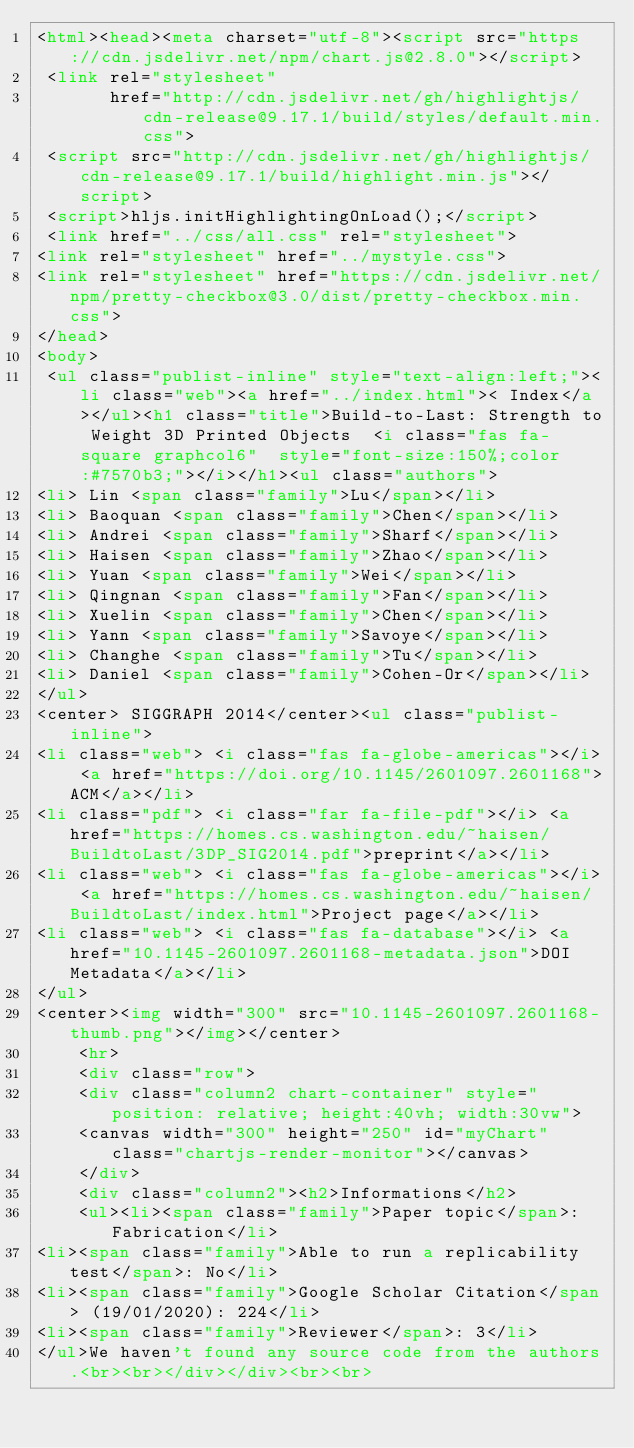<code> <loc_0><loc_0><loc_500><loc_500><_HTML_><html><head><meta charset="utf-8"><script src="https://cdn.jsdelivr.net/npm/chart.js@2.8.0"></script>
 <link rel="stylesheet"
       href="http://cdn.jsdelivr.net/gh/highlightjs/cdn-release@9.17.1/build/styles/default.min.css">
 <script src="http://cdn.jsdelivr.net/gh/highlightjs/cdn-release@9.17.1/build/highlight.min.js"></script>
 <script>hljs.initHighlightingOnLoad();</script>
 <link href="../css/all.css" rel="stylesheet">
<link rel="stylesheet" href="../mystyle.css">
<link rel="stylesheet" href="https://cdn.jsdelivr.net/npm/pretty-checkbox@3.0/dist/pretty-checkbox.min.css">
</head>
<body>
 <ul class="publist-inline" style="text-align:left;"><li class="web"><a href="../index.html">< Index</a></ul><h1 class="title">Build-to-Last: Strength to Weight 3D Printed Objects  <i class="fas fa-square graphcol6"  style="font-size:150%;color:#7570b3;"></i></h1><ul class="authors">
<li> Lin <span class="family">Lu</span></li>
<li> Baoquan <span class="family">Chen</span></li>
<li> Andrei <span class="family">Sharf</span></li>
<li> Haisen <span class="family">Zhao</span></li>
<li> Yuan <span class="family">Wei</span></li>
<li> Qingnan <span class="family">Fan</span></li>
<li> Xuelin <span class="family">Chen</span></li>
<li> Yann <span class="family">Savoye</span></li>
<li> Changhe <span class="family">Tu</span></li>
<li> Daniel <span class="family">Cohen-Or</span></li>
</ul>
<center> SIGGRAPH 2014</center><ul class="publist-inline">
<li class="web"> <i class="fas fa-globe-americas"></i> <a href="https://doi.org/10.1145/2601097.2601168">ACM</a></li>
<li class="pdf"> <i class="far fa-file-pdf"></i> <a href="https://homes.cs.washington.edu/~haisen/BuildtoLast/3DP_SIG2014.pdf">preprint</a></li>
<li class="web"> <i class="fas fa-globe-americas"></i> <a href="https://homes.cs.washington.edu/~haisen/BuildtoLast/index.html">Project page</a></li>
<li class="web"> <i class="fas fa-database"></i> <a href="10.1145-2601097.2601168-metadata.json">DOI Metadata</a></li>
</ul>
<center><img width="300" src="10.1145-2601097.2601168-thumb.png"></img></center>
    <hr>
    <div class="row">
    <div class="column2 chart-container" style="position: relative; height:40vh; width:30vw">
    <canvas width="300" height="250" id="myChart" class="chartjs-render-monitor"></canvas>
    </div>
    <div class="column2"><h2>Informations</h2>
    <ul><li><span class="family">Paper topic</span>: Fabrication</li>
<li><span class="family">Able to run a replicability test</span>: No</li>
<li><span class="family">Google Scholar Citation</span> (19/01/2020): 224</li>
<li><span class="family">Reviewer</span>: 3</li>
</ul>We haven't found any source code from the authors.<br><br></div></div><br><br></code> 